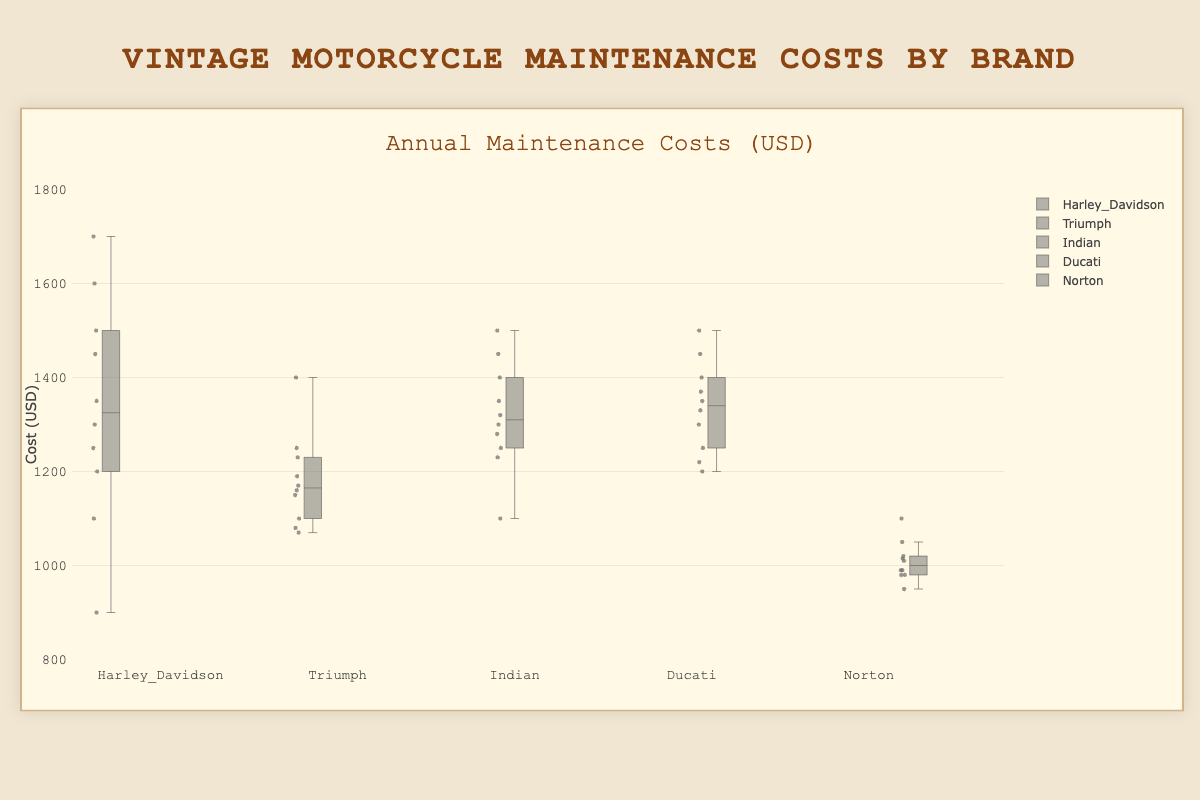What is the range of maintenance costs for Harley Davidson? To find the range, subtract the smallest value from the largest value. For Harley Davidson, the smallest value is 900 and the largest value is 1700. The range is \(1700 - 900 = 800\).
Answer: 800 Which motorcycle brand has the lowest median maintenance cost? The median is the middle value when the data points are ordered. By visually analyzing the box plot, the median value for each brand can be determined. Norton has the lowest median maintenance cost.
Answer: Norton What is the interquartile range (IQR) for Ducati? The IQR is the difference between the third quartile (Q3) and the first quartile (Q1). From the box plot, identify Q1 and Q3 for Ducati, which are around 1250 and 1400 respectively. Thus, the IQR is \(1400 - 1250 = 150\).
Answer: 150 Which motorcycle brand has the widest spread of maintenance costs? The spread of maintenance costs can be seen from the length of the boxes and whiskers. Harley Davidson has the widest spread of maintenance costs, as its range is the largest.
Answer: Harley Davidson Which brand has the highest maximum maintenance cost? Find the maximum values shown by the whiskers or outliers in the box plot. Harley Davidson has the highest maximum maintenance cost, which is 1700.
Answer: Harley Davidson How does the median maintenance cost of Indian compare to that of Triumph? By comparing the horizontal line within the boxes for Indian and Triumph, the median maintenance cost for Indian is higher than that for Triumph.
Answer: Indian is higher What is the approximate median maintenance cost for Norton? The median can be identified by the central horizontal line within the box. For Norton, it is around 1000.
Answer: 1000 Are there any outliers for the Ducati maintenance costs? Outliers are depicted as individual points beyond the whiskers. From the box plot, there are no outliers for Ducati.
Answer: No Compare the interquartile range (IQR) of Harley Davidson and Triumph. Which one is larger? Calculate the IQR for both. For Harley Davidson, it is approximately \(1500 - 1200 = 300\) and for Triumph, it is approximately \(1230 - 1150 = 80\). Harley Davidson's IQR is larger.
Answer: Harley Davidson What is the difference between the highest maintenance cost of Norton and the highest maintenance cost of Indian? The highest maintenance cost of Norton is around 1100, and for Indian, it is around 1500. The difference is \(1500 - 1100 = 400\).
Answer: 400 